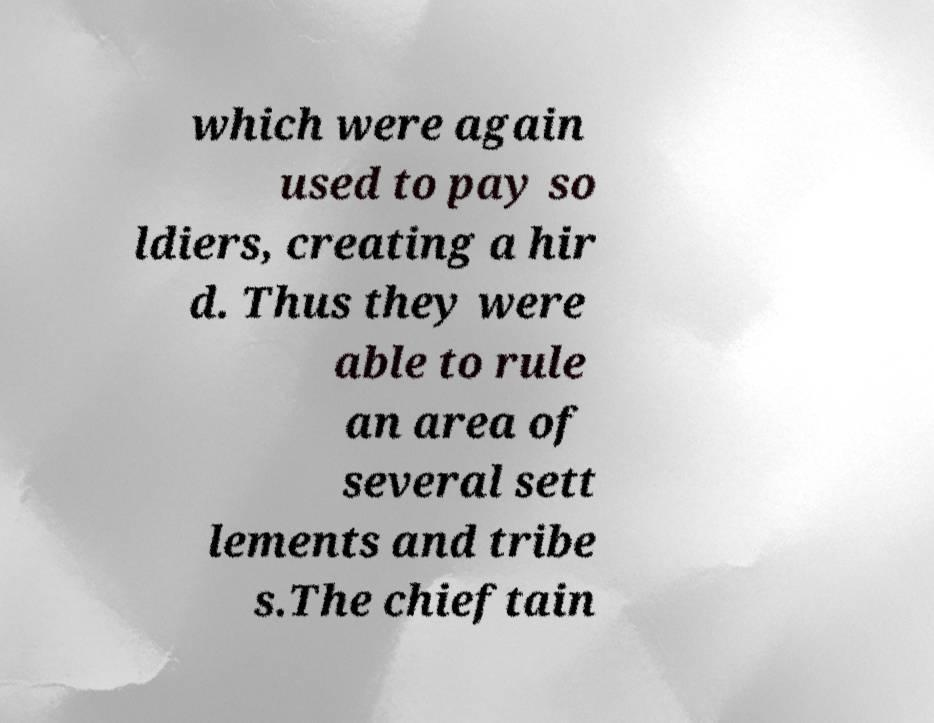Could you extract and type out the text from this image? which were again used to pay so ldiers, creating a hir d. Thus they were able to rule an area of several sett lements and tribe s.The chieftain 